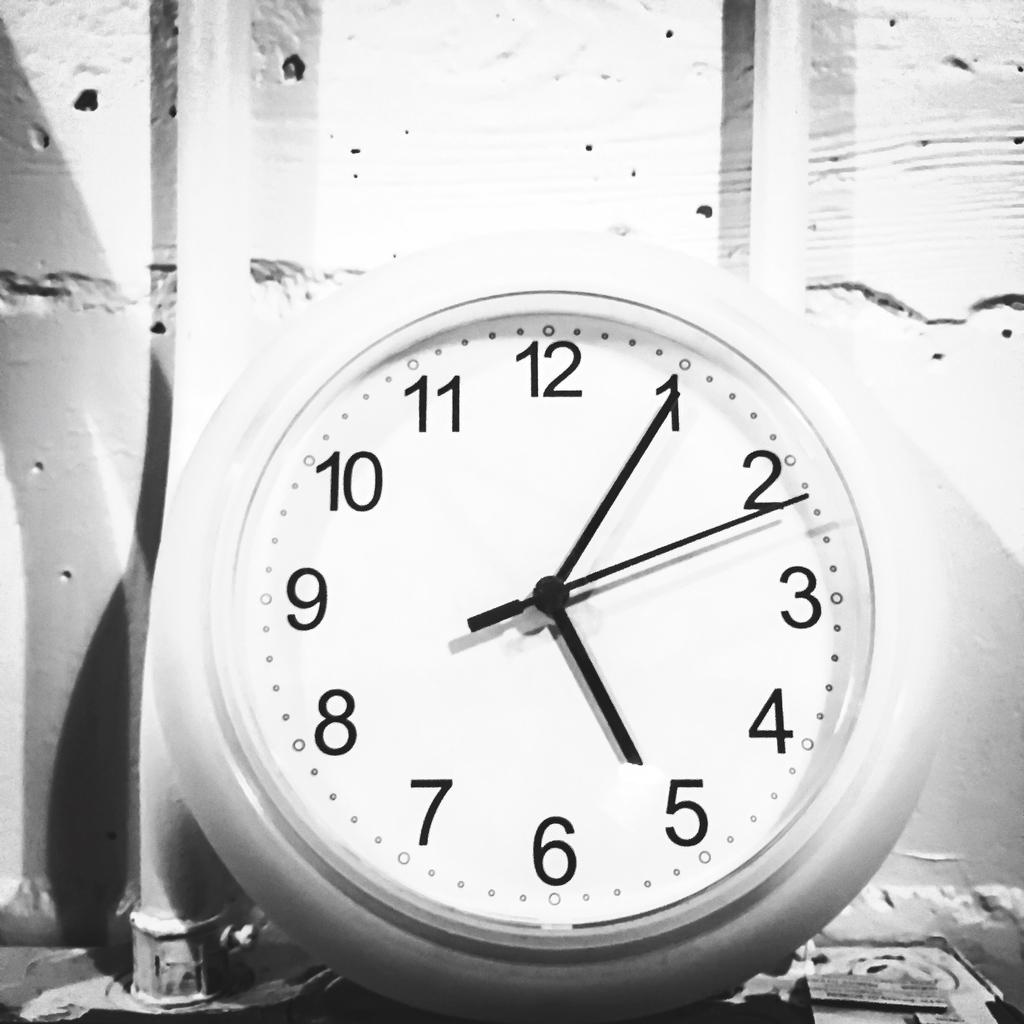<image>
Relay a brief, clear account of the picture shown. Black and white clock photo reads 5:05 and 11 seconds. 